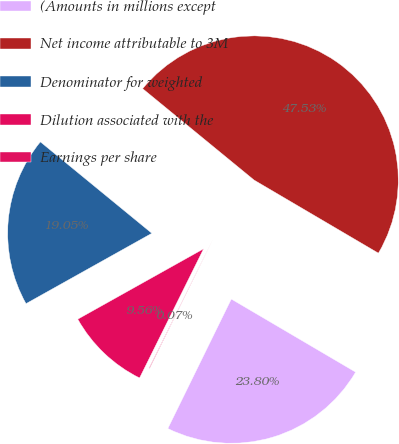<chart> <loc_0><loc_0><loc_500><loc_500><pie_chart><fcel>(Amounts in millions except<fcel>Net income attributable to 3M<fcel>Denominator for weighted<fcel>Dilution associated with the<fcel>Earnings per share<nl><fcel>23.8%<fcel>47.53%<fcel>19.05%<fcel>9.56%<fcel>0.07%<nl></chart> 